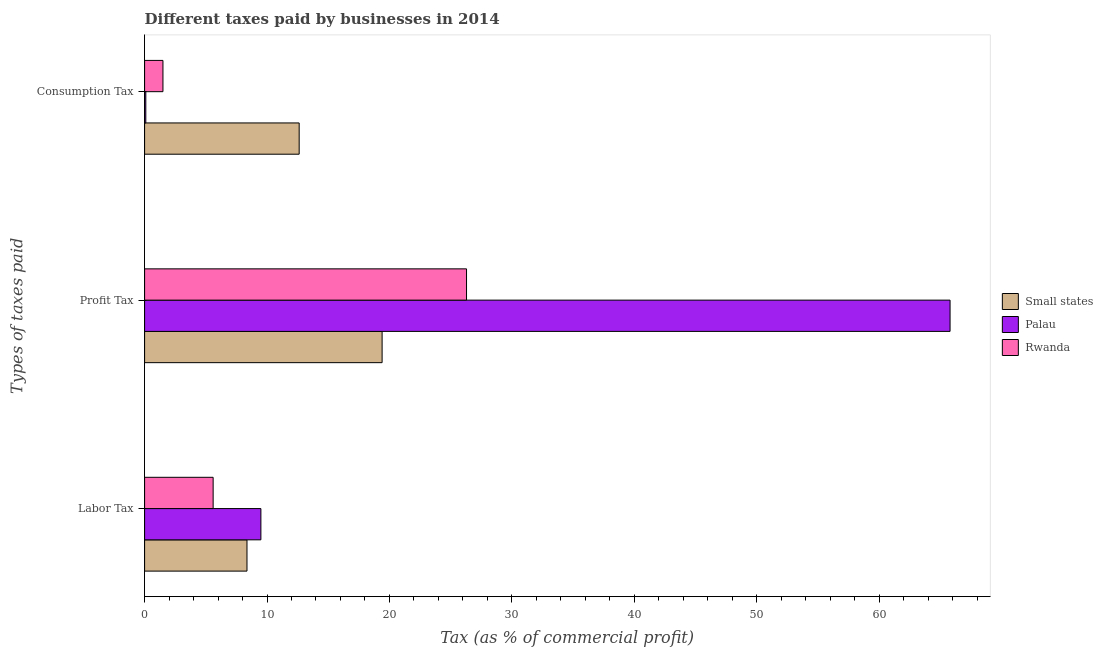How many groups of bars are there?
Your answer should be very brief. 3. Are the number of bars on each tick of the Y-axis equal?
Make the answer very short. Yes. How many bars are there on the 2nd tick from the bottom?
Keep it short and to the point. 3. What is the label of the 3rd group of bars from the top?
Your answer should be very brief. Labor Tax. What is the percentage of profit tax in Palau?
Make the answer very short. 65.8. Across all countries, what is the maximum percentage of profit tax?
Your answer should be compact. 65.8. Across all countries, what is the minimum percentage of labor tax?
Your answer should be compact. 5.6. In which country was the percentage of profit tax maximum?
Offer a very short reply. Palau. In which country was the percentage of consumption tax minimum?
Provide a succinct answer. Palau. What is the total percentage of consumption tax in the graph?
Your answer should be compact. 14.23. What is the difference between the percentage of labor tax in Small states and that in Rwanda?
Offer a terse response. 2.77. What is the difference between the percentage of profit tax in Rwanda and the percentage of labor tax in Palau?
Provide a short and direct response. 16.8. What is the average percentage of consumption tax per country?
Ensure brevity in your answer.  4.74. In how many countries, is the percentage of consumption tax greater than 48 %?
Make the answer very short. 0. What is the ratio of the percentage of profit tax in Rwanda to that in Small states?
Give a very brief answer. 1.36. Is the percentage of consumption tax in Palau less than that in Rwanda?
Provide a succinct answer. Yes. What is the difference between the highest and the second highest percentage of consumption tax?
Make the answer very short. 11.13. What is the difference between the highest and the lowest percentage of consumption tax?
Provide a short and direct response. 12.53. In how many countries, is the percentage of profit tax greater than the average percentage of profit tax taken over all countries?
Provide a short and direct response. 1. Is the sum of the percentage of labor tax in Palau and Rwanda greater than the maximum percentage of consumption tax across all countries?
Make the answer very short. Yes. What does the 2nd bar from the top in Profit Tax represents?
Offer a terse response. Palau. What does the 2nd bar from the bottom in Labor Tax represents?
Provide a short and direct response. Palau. Is it the case that in every country, the sum of the percentage of labor tax and percentage of profit tax is greater than the percentage of consumption tax?
Make the answer very short. Yes. Are all the bars in the graph horizontal?
Your answer should be very brief. Yes. What is the difference between two consecutive major ticks on the X-axis?
Provide a short and direct response. 10. Are the values on the major ticks of X-axis written in scientific E-notation?
Your answer should be very brief. No. Does the graph contain any zero values?
Offer a very short reply. No. Does the graph contain grids?
Your answer should be very brief. No. What is the title of the graph?
Offer a terse response. Different taxes paid by businesses in 2014. Does "Italy" appear as one of the legend labels in the graph?
Give a very brief answer. No. What is the label or title of the X-axis?
Your answer should be very brief. Tax (as % of commercial profit). What is the label or title of the Y-axis?
Your answer should be very brief. Types of taxes paid. What is the Tax (as % of commercial profit) in Small states in Labor Tax?
Offer a very short reply. 8.37. What is the Tax (as % of commercial profit) in Small states in Profit Tax?
Your answer should be very brief. 19.4. What is the Tax (as % of commercial profit) in Palau in Profit Tax?
Offer a very short reply. 65.8. What is the Tax (as % of commercial profit) in Rwanda in Profit Tax?
Make the answer very short. 26.3. What is the Tax (as % of commercial profit) in Small states in Consumption Tax?
Keep it short and to the point. 12.63. What is the Tax (as % of commercial profit) in Palau in Consumption Tax?
Provide a succinct answer. 0.1. Across all Types of taxes paid, what is the maximum Tax (as % of commercial profit) of Small states?
Make the answer very short. 19.4. Across all Types of taxes paid, what is the maximum Tax (as % of commercial profit) in Palau?
Your answer should be very brief. 65.8. Across all Types of taxes paid, what is the maximum Tax (as % of commercial profit) in Rwanda?
Your answer should be compact. 26.3. Across all Types of taxes paid, what is the minimum Tax (as % of commercial profit) of Small states?
Offer a terse response. 8.37. What is the total Tax (as % of commercial profit) of Small states in the graph?
Your answer should be compact. 40.4. What is the total Tax (as % of commercial profit) in Palau in the graph?
Give a very brief answer. 75.4. What is the total Tax (as % of commercial profit) of Rwanda in the graph?
Provide a succinct answer. 33.4. What is the difference between the Tax (as % of commercial profit) of Small states in Labor Tax and that in Profit Tax?
Your answer should be very brief. -11.04. What is the difference between the Tax (as % of commercial profit) in Palau in Labor Tax and that in Profit Tax?
Make the answer very short. -56.3. What is the difference between the Tax (as % of commercial profit) of Rwanda in Labor Tax and that in Profit Tax?
Your answer should be very brief. -20.7. What is the difference between the Tax (as % of commercial profit) in Small states in Labor Tax and that in Consumption Tax?
Provide a short and direct response. -4.26. What is the difference between the Tax (as % of commercial profit) in Palau in Labor Tax and that in Consumption Tax?
Your answer should be very brief. 9.4. What is the difference between the Tax (as % of commercial profit) in Rwanda in Labor Tax and that in Consumption Tax?
Provide a succinct answer. 4.1. What is the difference between the Tax (as % of commercial profit) of Small states in Profit Tax and that in Consumption Tax?
Give a very brief answer. 6.78. What is the difference between the Tax (as % of commercial profit) of Palau in Profit Tax and that in Consumption Tax?
Your response must be concise. 65.7. What is the difference between the Tax (as % of commercial profit) of Rwanda in Profit Tax and that in Consumption Tax?
Offer a very short reply. 24.8. What is the difference between the Tax (as % of commercial profit) in Small states in Labor Tax and the Tax (as % of commercial profit) in Palau in Profit Tax?
Provide a short and direct response. -57.44. What is the difference between the Tax (as % of commercial profit) in Small states in Labor Tax and the Tax (as % of commercial profit) in Rwanda in Profit Tax?
Your answer should be compact. -17.93. What is the difference between the Tax (as % of commercial profit) in Palau in Labor Tax and the Tax (as % of commercial profit) in Rwanda in Profit Tax?
Your answer should be very brief. -16.8. What is the difference between the Tax (as % of commercial profit) of Small states in Labor Tax and the Tax (as % of commercial profit) of Palau in Consumption Tax?
Make the answer very short. 8.27. What is the difference between the Tax (as % of commercial profit) of Small states in Labor Tax and the Tax (as % of commercial profit) of Rwanda in Consumption Tax?
Ensure brevity in your answer.  6.87. What is the difference between the Tax (as % of commercial profit) in Small states in Profit Tax and the Tax (as % of commercial profit) in Palau in Consumption Tax?
Offer a terse response. 19.3. What is the difference between the Tax (as % of commercial profit) of Small states in Profit Tax and the Tax (as % of commercial profit) of Rwanda in Consumption Tax?
Your response must be concise. 17.9. What is the difference between the Tax (as % of commercial profit) of Palau in Profit Tax and the Tax (as % of commercial profit) of Rwanda in Consumption Tax?
Make the answer very short. 64.3. What is the average Tax (as % of commercial profit) of Small states per Types of taxes paid?
Your answer should be compact. 13.46. What is the average Tax (as % of commercial profit) of Palau per Types of taxes paid?
Provide a short and direct response. 25.13. What is the average Tax (as % of commercial profit) in Rwanda per Types of taxes paid?
Make the answer very short. 11.13. What is the difference between the Tax (as % of commercial profit) of Small states and Tax (as % of commercial profit) of Palau in Labor Tax?
Your answer should be very brief. -1.14. What is the difference between the Tax (as % of commercial profit) in Small states and Tax (as % of commercial profit) in Rwanda in Labor Tax?
Provide a succinct answer. 2.77. What is the difference between the Tax (as % of commercial profit) of Small states and Tax (as % of commercial profit) of Palau in Profit Tax?
Offer a very short reply. -46.4. What is the difference between the Tax (as % of commercial profit) of Small states and Tax (as % of commercial profit) of Rwanda in Profit Tax?
Ensure brevity in your answer.  -6.9. What is the difference between the Tax (as % of commercial profit) in Palau and Tax (as % of commercial profit) in Rwanda in Profit Tax?
Your answer should be very brief. 39.5. What is the difference between the Tax (as % of commercial profit) of Small states and Tax (as % of commercial profit) of Palau in Consumption Tax?
Offer a very short reply. 12.53. What is the difference between the Tax (as % of commercial profit) in Small states and Tax (as % of commercial profit) in Rwanda in Consumption Tax?
Your answer should be very brief. 11.13. What is the difference between the Tax (as % of commercial profit) in Palau and Tax (as % of commercial profit) in Rwanda in Consumption Tax?
Give a very brief answer. -1.4. What is the ratio of the Tax (as % of commercial profit) of Small states in Labor Tax to that in Profit Tax?
Your answer should be compact. 0.43. What is the ratio of the Tax (as % of commercial profit) in Palau in Labor Tax to that in Profit Tax?
Make the answer very short. 0.14. What is the ratio of the Tax (as % of commercial profit) in Rwanda in Labor Tax to that in Profit Tax?
Your answer should be compact. 0.21. What is the ratio of the Tax (as % of commercial profit) in Small states in Labor Tax to that in Consumption Tax?
Provide a short and direct response. 0.66. What is the ratio of the Tax (as % of commercial profit) of Rwanda in Labor Tax to that in Consumption Tax?
Make the answer very short. 3.73. What is the ratio of the Tax (as % of commercial profit) of Small states in Profit Tax to that in Consumption Tax?
Your answer should be compact. 1.54. What is the ratio of the Tax (as % of commercial profit) of Palau in Profit Tax to that in Consumption Tax?
Offer a very short reply. 658. What is the ratio of the Tax (as % of commercial profit) in Rwanda in Profit Tax to that in Consumption Tax?
Provide a succinct answer. 17.53. What is the difference between the highest and the second highest Tax (as % of commercial profit) of Small states?
Give a very brief answer. 6.78. What is the difference between the highest and the second highest Tax (as % of commercial profit) in Palau?
Offer a very short reply. 56.3. What is the difference between the highest and the second highest Tax (as % of commercial profit) of Rwanda?
Offer a terse response. 20.7. What is the difference between the highest and the lowest Tax (as % of commercial profit) in Small states?
Provide a succinct answer. 11.04. What is the difference between the highest and the lowest Tax (as % of commercial profit) in Palau?
Offer a terse response. 65.7. What is the difference between the highest and the lowest Tax (as % of commercial profit) of Rwanda?
Your answer should be very brief. 24.8. 